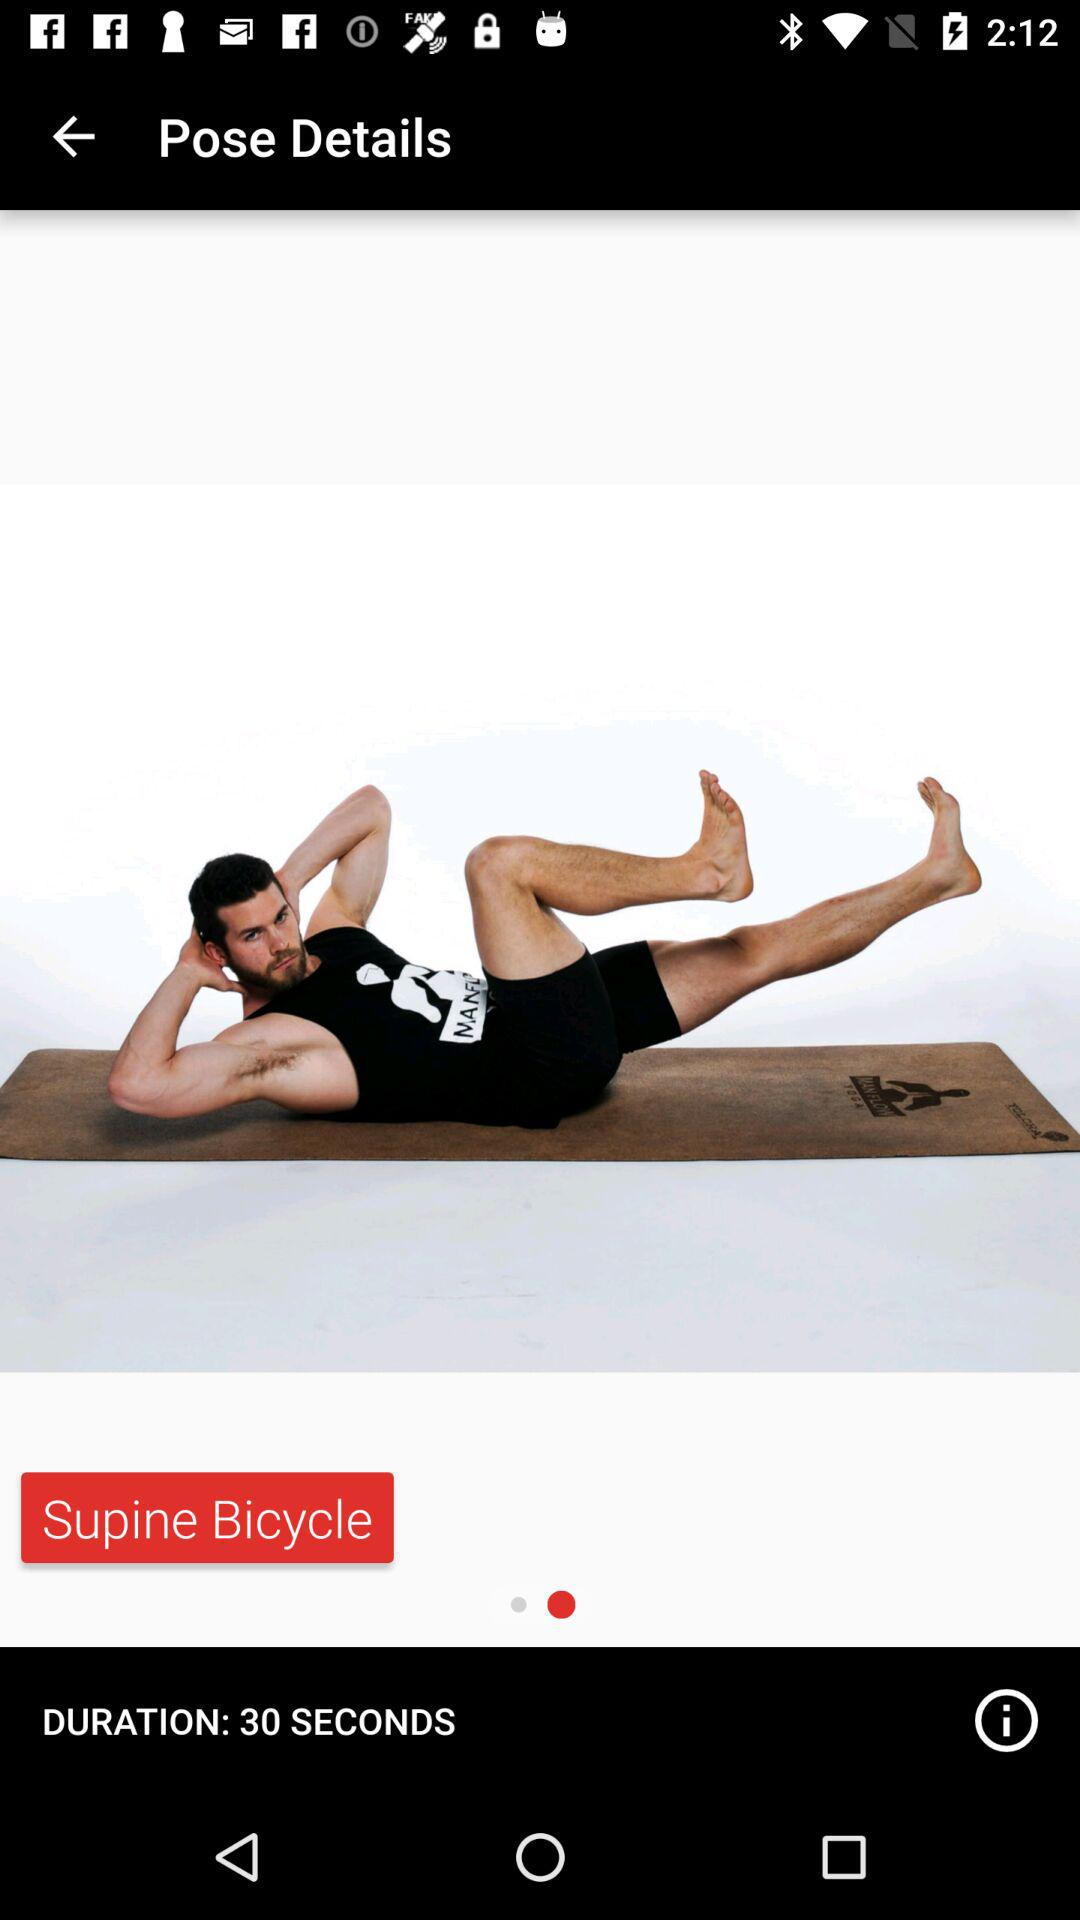What is the name of the exercise? The name of the exercise is "Supine Bicycle". 